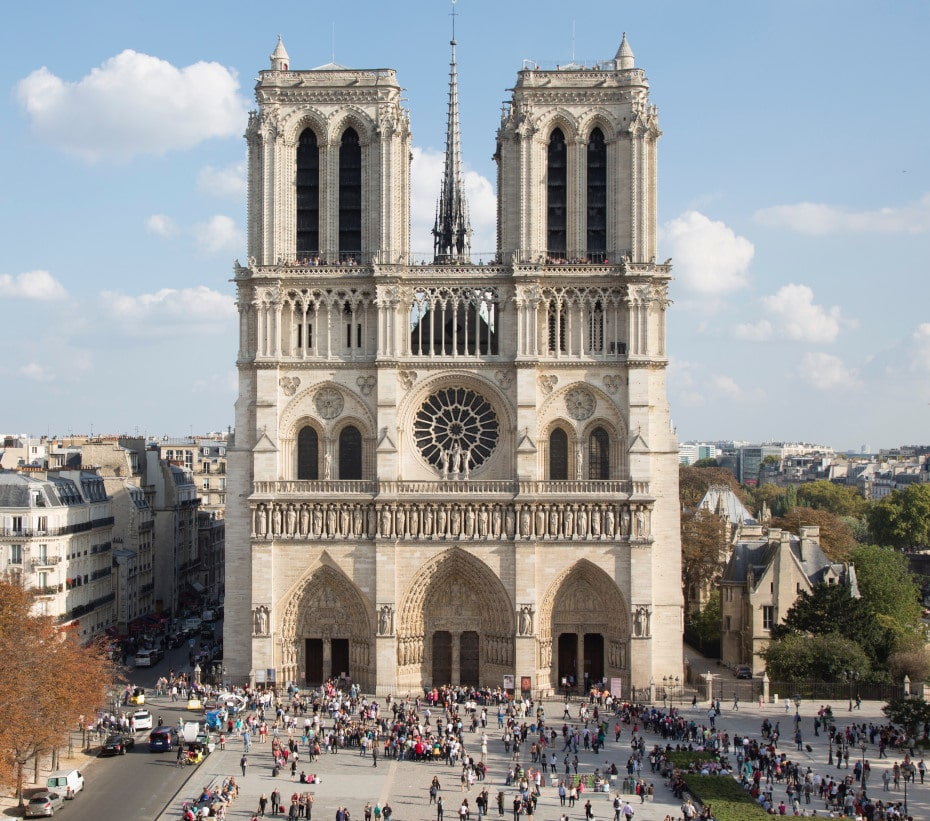Analyze the image in a comprehensive and detailed manner. The image showcases the Notre Dame Cathedral, an exemplar of French Gothic architecture, located in Paris, France. Captured from a frontal and slightly elevated angle, this view highlights the cathedral's magnificent facade made from light-colored stone, which has stood the test of time. The facade is distinguished by its two massive towers, each adorned with intricately designed arched windows and crowned with pointed spires that enhance the vertical lift typical of Gothic design. The large rose window positioned centrally above the portal is a focal point, its detailed craftsmanship a testament to medieval artistry.

A significant feature missed in earlier descriptions is the reconstruction of the central spire, historically added in the 19th century and destroyed in a 2019 fire, indicating ongoing restoration efforts. Furthermore, the bustling square filled with people and the flanking Haussmannian buildings suggest the cathedral's integral role in the daily life and urban fabric of Paris. This image captures not only the architectural glory of Notre Dame but also its enduring place in the heart of a modern metropolis. 